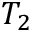Convert formula to latex. <formula><loc_0><loc_0><loc_500><loc_500>T _ { 2 }</formula> 